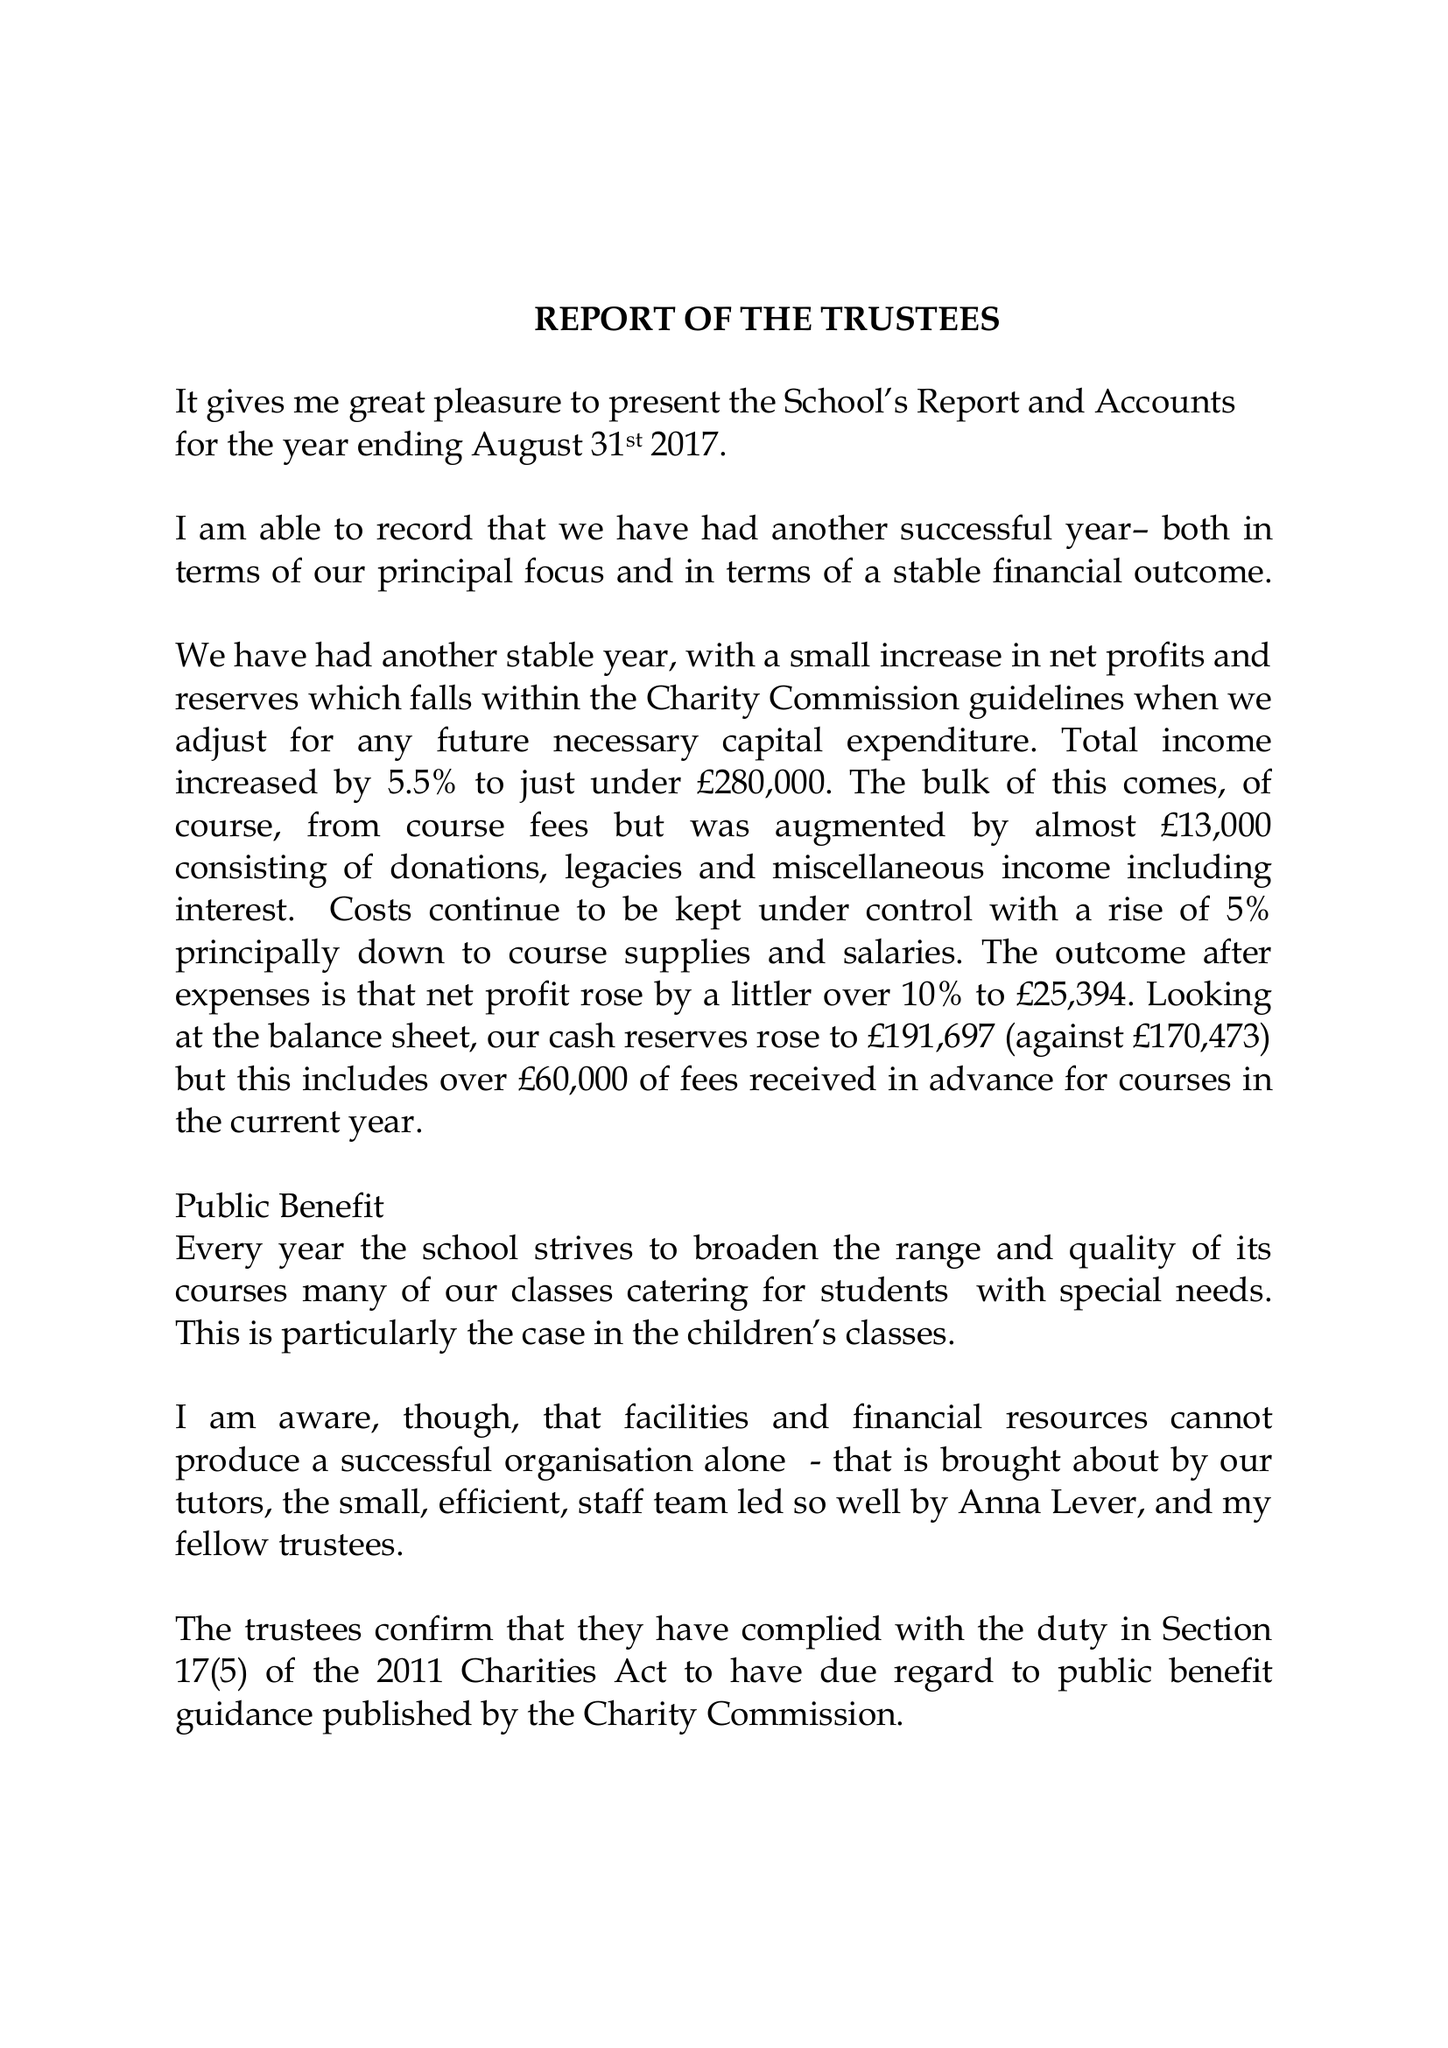What is the value for the income_annually_in_british_pounds?
Answer the question using a single word or phrase. 279873.00 